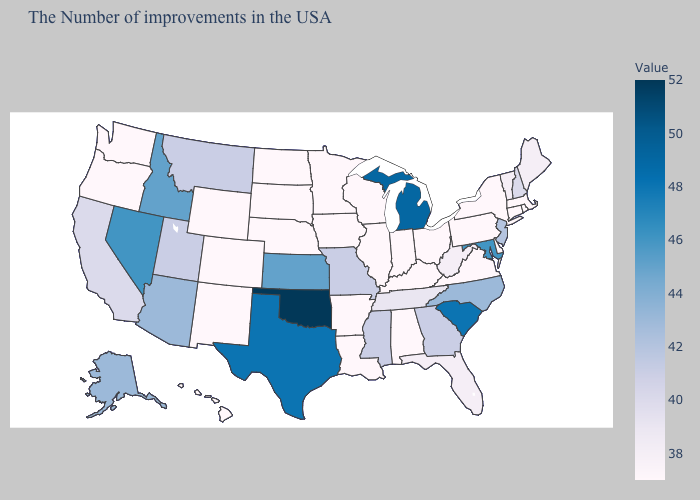Among the states that border Florida , does Georgia have the highest value?
Give a very brief answer. Yes. Which states have the lowest value in the West?
Quick response, please. Wyoming, Colorado, New Mexico, Washington, Oregon, Hawaii. Does Michigan have the highest value in the MidWest?
Concise answer only. Yes. Among the states that border Alabama , which have the highest value?
Give a very brief answer. Georgia, Mississippi. Among the states that border Ohio , which have the lowest value?
Answer briefly. Pennsylvania, Kentucky, Indiana. Among the states that border Georgia , which have the lowest value?
Give a very brief answer. Alabama. 